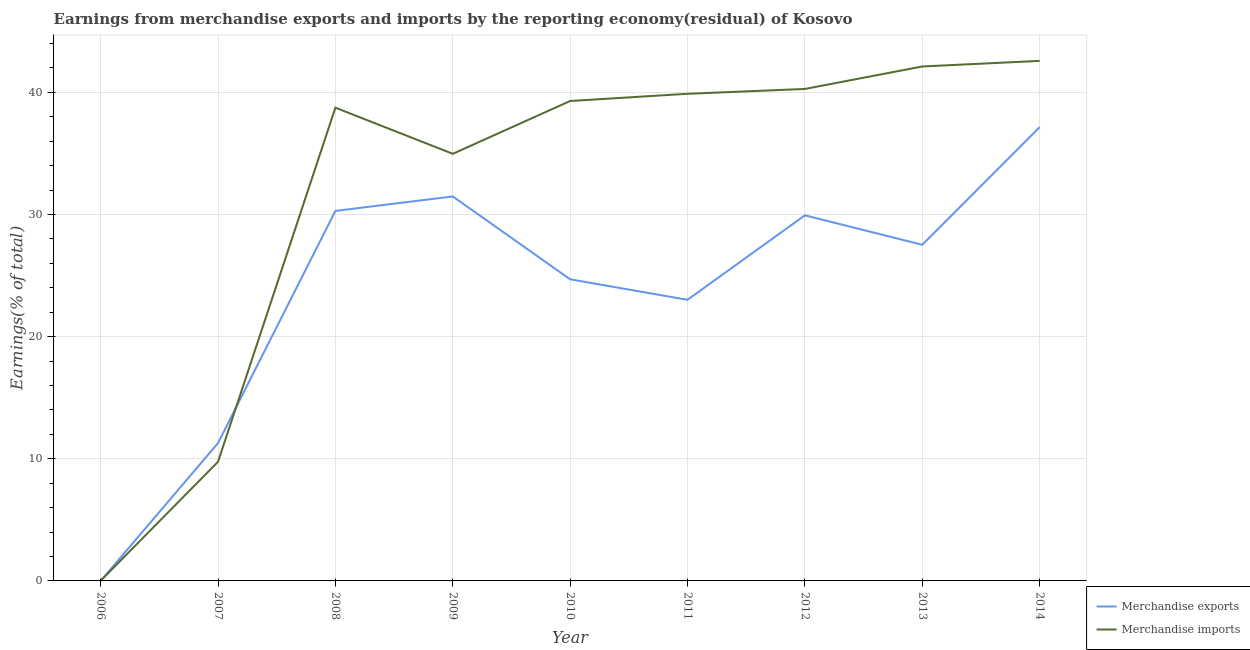Is the number of lines equal to the number of legend labels?
Make the answer very short. Yes. What is the earnings from merchandise imports in 2011?
Your answer should be very brief. 39.88. Across all years, what is the maximum earnings from merchandise imports?
Your answer should be compact. 42.57. Across all years, what is the minimum earnings from merchandise imports?
Your answer should be very brief. 0.01. In which year was the earnings from merchandise imports maximum?
Make the answer very short. 2014. What is the total earnings from merchandise exports in the graph?
Your answer should be compact. 215.36. What is the difference between the earnings from merchandise exports in 2006 and that in 2008?
Make the answer very short. -30.29. What is the difference between the earnings from merchandise imports in 2013 and the earnings from merchandise exports in 2008?
Provide a succinct answer. 11.82. What is the average earnings from merchandise exports per year?
Make the answer very short. 23.93. In the year 2009, what is the difference between the earnings from merchandise exports and earnings from merchandise imports?
Keep it short and to the point. -3.49. In how many years, is the earnings from merchandise imports greater than 14 %?
Provide a succinct answer. 7. What is the ratio of the earnings from merchandise exports in 2008 to that in 2014?
Keep it short and to the point. 0.82. What is the difference between the highest and the second highest earnings from merchandise exports?
Give a very brief answer. 5.67. What is the difference between the highest and the lowest earnings from merchandise exports?
Your response must be concise. 37.15. In how many years, is the earnings from merchandise exports greater than the average earnings from merchandise exports taken over all years?
Make the answer very short. 6. Is the sum of the earnings from merchandise imports in 2006 and 2009 greater than the maximum earnings from merchandise exports across all years?
Provide a short and direct response. No. How many lines are there?
Provide a short and direct response. 2. How many years are there in the graph?
Give a very brief answer. 9. What is the difference between two consecutive major ticks on the Y-axis?
Ensure brevity in your answer.  10. Are the values on the major ticks of Y-axis written in scientific E-notation?
Your answer should be very brief. No. Where does the legend appear in the graph?
Make the answer very short. Bottom right. How are the legend labels stacked?
Your answer should be very brief. Vertical. What is the title of the graph?
Keep it short and to the point. Earnings from merchandise exports and imports by the reporting economy(residual) of Kosovo. What is the label or title of the Y-axis?
Keep it short and to the point. Earnings(% of total). What is the Earnings(% of total) in Merchandise exports in 2006?
Your response must be concise. 7.80569519437283e-9. What is the Earnings(% of total) in Merchandise imports in 2006?
Offer a terse response. 0.01. What is the Earnings(% of total) in Merchandise exports in 2007?
Give a very brief answer. 11.29. What is the Earnings(% of total) of Merchandise imports in 2007?
Offer a terse response. 9.76. What is the Earnings(% of total) of Merchandise exports in 2008?
Offer a terse response. 30.29. What is the Earnings(% of total) in Merchandise imports in 2008?
Give a very brief answer. 38.74. What is the Earnings(% of total) in Merchandise exports in 2009?
Your answer should be very brief. 31.48. What is the Earnings(% of total) of Merchandise imports in 2009?
Your answer should be compact. 34.97. What is the Earnings(% of total) in Merchandise exports in 2010?
Your answer should be compact. 24.69. What is the Earnings(% of total) in Merchandise imports in 2010?
Keep it short and to the point. 39.29. What is the Earnings(% of total) of Merchandise exports in 2011?
Make the answer very short. 23.02. What is the Earnings(% of total) of Merchandise imports in 2011?
Make the answer very short. 39.88. What is the Earnings(% of total) of Merchandise exports in 2012?
Give a very brief answer. 29.93. What is the Earnings(% of total) in Merchandise imports in 2012?
Your response must be concise. 40.28. What is the Earnings(% of total) in Merchandise exports in 2013?
Give a very brief answer. 27.52. What is the Earnings(% of total) in Merchandise imports in 2013?
Your response must be concise. 42.12. What is the Earnings(% of total) in Merchandise exports in 2014?
Make the answer very short. 37.15. What is the Earnings(% of total) of Merchandise imports in 2014?
Your answer should be very brief. 42.57. Across all years, what is the maximum Earnings(% of total) in Merchandise exports?
Give a very brief answer. 37.15. Across all years, what is the maximum Earnings(% of total) in Merchandise imports?
Make the answer very short. 42.57. Across all years, what is the minimum Earnings(% of total) of Merchandise exports?
Keep it short and to the point. 7.80569519437283e-9. Across all years, what is the minimum Earnings(% of total) of Merchandise imports?
Your answer should be compact. 0.01. What is the total Earnings(% of total) of Merchandise exports in the graph?
Offer a very short reply. 215.36. What is the total Earnings(% of total) of Merchandise imports in the graph?
Your answer should be very brief. 287.61. What is the difference between the Earnings(% of total) in Merchandise exports in 2006 and that in 2007?
Give a very brief answer. -11.29. What is the difference between the Earnings(% of total) of Merchandise imports in 2006 and that in 2007?
Offer a very short reply. -9.74. What is the difference between the Earnings(% of total) in Merchandise exports in 2006 and that in 2008?
Your answer should be compact. -30.29. What is the difference between the Earnings(% of total) in Merchandise imports in 2006 and that in 2008?
Provide a short and direct response. -38.73. What is the difference between the Earnings(% of total) in Merchandise exports in 2006 and that in 2009?
Offer a terse response. -31.48. What is the difference between the Earnings(% of total) in Merchandise imports in 2006 and that in 2009?
Your answer should be compact. -34.95. What is the difference between the Earnings(% of total) in Merchandise exports in 2006 and that in 2010?
Provide a short and direct response. -24.69. What is the difference between the Earnings(% of total) in Merchandise imports in 2006 and that in 2010?
Offer a terse response. -39.28. What is the difference between the Earnings(% of total) of Merchandise exports in 2006 and that in 2011?
Make the answer very short. -23.02. What is the difference between the Earnings(% of total) of Merchandise imports in 2006 and that in 2011?
Your answer should be compact. -39.87. What is the difference between the Earnings(% of total) in Merchandise exports in 2006 and that in 2012?
Give a very brief answer. -29.93. What is the difference between the Earnings(% of total) in Merchandise imports in 2006 and that in 2012?
Your answer should be very brief. -40.26. What is the difference between the Earnings(% of total) of Merchandise exports in 2006 and that in 2013?
Give a very brief answer. -27.52. What is the difference between the Earnings(% of total) in Merchandise imports in 2006 and that in 2013?
Keep it short and to the point. -42.1. What is the difference between the Earnings(% of total) in Merchandise exports in 2006 and that in 2014?
Offer a terse response. -37.15. What is the difference between the Earnings(% of total) in Merchandise imports in 2006 and that in 2014?
Ensure brevity in your answer.  -42.56. What is the difference between the Earnings(% of total) of Merchandise exports in 2007 and that in 2008?
Provide a succinct answer. -19.01. What is the difference between the Earnings(% of total) of Merchandise imports in 2007 and that in 2008?
Provide a short and direct response. -28.99. What is the difference between the Earnings(% of total) of Merchandise exports in 2007 and that in 2009?
Keep it short and to the point. -20.19. What is the difference between the Earnings(% of total) of Merchandise imports in 2007 and that in 2009?
Keep it short and to the point. -25.21. What is the difference between the Earnings(% of total) of Merchandise exports in 2007 and that in 2010?
Ensure brevity in your answer.  -13.4. What is the difference between the Earnings(% of total) in Merchandise imports in 2007 and that in 2010?
Your answer should be compact. -29.53. What is the difference between the Earnings(% of total) of Merchandise exports in 2007 and that in 2011?
Offer a terse response. -11.73. What is the difference between the Earnings(% of total) in Merchandise imports in 2007 and that in 2011?
Offer a very short reply. -30.12. What is the difference between the Earnings(% of total) in Merchandise exports in 2007 and that in 2012?
Ensure brevity in your answer.  -18.64. What is the difference between the Earnings(% of total) of Merchandise imports in 2007 and that in 2012?
Give a very brief answer. -30.52. What is the difference between the Earnings(% of total) in Merchandise exports in 2007 and that in 2013?
Your answer should be very brief. -16.23. What is the difference between the Earnings(% of total) in Merchandise imports in 2007 and that in 2013?
Provide a succinct answer. -32.36. What is the difference between the Earnings(% of total) of Merchandise exports in 2007 and that in 2014?
Offer a very short reply. -25.86. What is the difference between the Earnings(% of total) of Merchandise imports in 2007 and that in 2014?
Keep it short and to the point. -32.82. What is the difference between the Earnings(% of total) of Merchandise exports in 2008 and that in 2009?
Your answer should be very brief. -1.18. What is the difference between the Earnings(% of total) in Merchandise imports in 2008 and that in 2009?
Make the answer very short. 3.78. What is the difference between the Earnings(% of total) of Merchandise exports in 2008 and that in 2010?
Offer a very short reply. 5.6. What is the difference between the Earnings(% of total) of Merchandise imports in 2008 and that in 2010?
Make the answer very short. -0.55. What is the difference between the Earnings(% of total) in Merchandise exports in 2008 and that in 2011?
Keep it short and to the point. 7.28. What is the difference between the Earnings(% of total) in Merchandise imports in 2008 and that in 2011?
Offer a very short reply. -1.14. What is the difference between the Earnings(% of total) of Merchandise exports in 2008 and that in 2012?
Give a very brief answer. 0.36. What is the difference between the Earnings(% of total) in Merchandise imports in 2008 and that in 2012?
Make the answer very short. -1.53. What is the difference between the Earnings(% of total) in Merchandise exports in 2008 and that in 2013?
Offer a terse response. 2.77. What is the difference between the Earnings(% of total) of Merchandise imports in 2008 and that in 2013?
Provide a short and direct response. -3.37. What is the difference between the Earnings(% of total) in Merchandise exports in 2008 and that in 2014?
Your response must be concise. -6.86. What is the difference between the Earnings(% of total) of Merchandise imports in 2008 and that in 2014?
Your answer should be compact. -3.83. What is the difference between the Earnings(% of total) of Merchandise exports in 2009 and that in 2010?
Provide a succinct answer. 6.79. What is the difference between the Earnings(% of total) in Merchandise imports in 2009 and that in 2010?
Provide a succinct answer. -4.32. What is the difference between the Earnings(% of total) of Merchandise exports in 2009 and that in 2011?
Provide a short and direct response. 8.46. What is the difference between the Earnings(% of total) of Merchandise imports in 2009 and that in 2011?
Your answer should be very brief. -4.91. What is the difference between the Earnings(% of total) in Merchandise exports in 2009 and that in 2012?
Ensure brevity in your answer.  1.55. What is the difference between the Earnings(% of total) in Merchandise imports in 2009 and that in 2012?
Make the answer very short. -5.31. What is the difference between the Earnings(% of total) of Merchandise exports in 2009 and that in 2013?
Give a very brief answer. 3.96. What is the difference between the Earnings(% of total) in Merchandise imports in 2009 and that in 2013?
Your response must be concise. -7.15. What is the difference between the Earnings(% of total) in Merchandise exports in 2009 and that in 2014?
Make the answer very short. -5.67. What is the difference between the Earnings(% of total) in Merchandise imports in 2009 and that in 2014?
Make the answer very short. -7.61. What is the difference between the Earnings(% of total) of Merchandise exports in 2010 and that in 2011?
Your answer should be very brief. 1.68. What is the difference between the Earnings(% of total) of Merchandise imports in 2010 and that in 2011?
Your answer should be compact. -0.59. What is the difference between the Earnings(% of total) of Merchandise exports in 2010 and that in 2012?
Your answer should be very brief. -5.24. What is the difference between the Earnings(% of total) of Merchandise imports in 2010 and that in 2012?
Your answer should be very brief. -0.99. What is the difference between the Earnings(% of total) of Merchandise exports in 2010 and that in 2013?
Provide a succinct answer. -2.83. What is the difference between the Earnings(% of total) in Merchandise imports in 2010 and that in 2013?
Offer a very short reply. -2.83. What is the difference between the Earnings(% of total) of Merchandise exports in 2010 and that in 2014?
Your answer should be very brief. -12.46. What is the difference between the Earnings(% of total) of Merchandise imports in 2010 and that in 2014?
Make the answer very short. -3.28. What is the difference between the Earnings(% of total) in Merchandise exports in 2011 and that in 2012?
Provide a succinct answer. -6.92. What is the difference between the Earnings(% of total) of Merchandise imports in 2011 and that in 2012?
Your answer should be very brief. -0.4. What is the difference between the Earnings(% of total) of Merchandise exports in 2011 and that in 2013?
Your answer should be very brief. -4.5. What is the difference between the Earnings(% of total) in Merchandise imports in 2011 and that in 2013?
Provide a short and direct response. -2.24. What is the difference between the Earnings(% of total) in Merchandise exports in 2011 and that in 2014?
Offer a very short reply. -14.14. What is the difference between the Earnings(% of total) in Merchandise imports in 2011 and that in 2014?
Provide a succinct answer. -2.69. What is the difference between the Earnings(% of total) in Merchandise exports in 2012 and that in 2013?
Your answer should be compact. 2.41. What is the difference between the Earnings(% of total) of Merchandise imports in 2012 and that in 2013?
Offer a very short reply. -1.84. What is the difference between the Earnings(% of total) of Merchandise exports in 2012 and that in 2014?
Offer a terse response. -7.22. What is the difference between the Earnings(% of total) of Merchandise imports in 2012 and that in 2014?
Your answer should be compact. -2.3. What is the difference between the Earnings(% of total) of Merchandise exports in 2013 and that in 2014?
Your response must be concise. -9.63. What is the difference between the Earnings(% of total) in Merchandise imports in 2013 and that in 2014?
Offer a very short reply. -0.46. What is the difference between the Earnings(% of total) of Merchandise exports in 2006 and the Earnings(% of total) of Merchandise imports in 2007?
Offer a terse response. -9.76. What is the difference between the Earnings(% of total) in Merchandise exports in 2006 and the Earnings(% of total) in Merchandise imports in 2008?
Give a very brief answer. -38.74. What is the difference between the Earnings(% of total) in Merchandise exports in 2006 and the Earnings(% of total) in Merchandise imports in 2009?
Provide a succinct answer. -34.97. What is the difference between the Earnings(% of total) in Merchandise exports in 2006 and the Earnings(% of total) in Merchandise imports in 2010?
Make the answer very short. -39.29. What is the difference between the Earnings(% of total) in Merchandise exports in 2006 and the Earnings(% of total) in Merchandise imports in 2011?
Keep it short and to the point. -39.88. What is the difference between the Earnings(% of total) in Merchandise exports in 2006 and the Earnings(% of total) in Merchandise imports in 2012?
Provide a short and direct response. -40.28. What is the difference between the Earnings(% of total) of Merchandise exports in 2006 and the Earnings(% of total) of Merchandise imports in 2013?
Give a very brief answer. -42.12. What is the difference between the Earnings(% of total) in Merchandise exports in 2006 and the Earnings(% of total) in Merchandise imports in 2014?
Provide a succinct answer. -42.57. What is the difference between the Earnings(% of total) of Merchandise exports in 2007 and the Earnings(% of total) of Merchandise imports in 2008?
Offer a very short reply. -27.46. What is the difference between the Earnings(% of total) in Merchandise exports in 2007 and the Earnings(% of total) in Merchandise imports in 2009?
Offer a very short reply. -23.68. What is the difference between the Earnings(% of total) of Merchandise exports in 2007 and the Earnings(% of total) of Merchandise imports in 2010?
Provide a short and direct response. -28. What is the difference between the Earnings(% of total) in Merchandise exports in 2007 and the Earnings(% of total) in Merchandise imports in 2011?
Give a very brief answer. -28.59. What is the difference between the Earnings(% of total) in Merchandise exports in 2007 and the Earnings(% of total) in Merchandise imports in 2012?
Offer a very short reply. -28.99. What is the difference between the Earnings(% of total) of Merchandise exports in 2007 and the Earnings(% of total) of Merchandise imports in 2013?
Your answer should be very brief. -30.83. What is the difference between the Earnings(% of total) of Merchandise exports in 2007 and the Earnings(% of total) of Merchandise imports in 2014?
Your response must be concise. -31.29. What is the difference between the Earnings(% of total) of Merchandise exports in 2008 and the Earnings(% of total) of Merchandise imports in 2009?
Offer a terse response. -4.67. What is the difference between the Earnings(% of total) in Merchandise exports in 2008 and the Earnings(% of total) in Merchandise imports in 2010?
Give a very brief answer. -9. What is the difference between the Earnings(% of total) of Merchandise exports in 2008 and the Earnings(% of total) of Merchandise imports in 2011?
Give a very brief answer. -9.59. What is the difference between the Earnings(% of total) in Merchandise exports in 2008 and the Earnings(% of total) in Merchandise imports in 2012?
Make the answer very short. -9.98. What is the difference between the Earnings(% of total) in Merchandise exports in 2008 and the Earnings(% of total) in Merchandise imports in 2013?
Keep it short and to the point. -11.82. What is the difference between the Earnings(% of total) in Merchandise exports in 2008 and the Earnings(% of total) in Merchandise imports in 2014?
Keep it short and to the point. -12.28. What is the difference between the Earnings(% of total) of Merchandise exports in 2009 and the Earnings(% of total) of Merchandise imports in 2010?
Your answer should be very brief. -7.81. What is the difference between the Earnings(% of total) in Merchandise exports in 2009 and the Earnings(% of total) in Merchandise imports in 2011?
Make the answer very short. -8.4. What is the difference between the Earnings(% of total) of Merchandise exports in 2009 and the Earnings(% of total) of Merchandise imports in 2012?
Your answer should be very brief. -8.8. What is the difference between the Earnings(% of total) in Merchandise exports in 2009 and the Earnings(% of total) in Merchandise imports in 2013?
Offer a very short reply. -10.64. What is the difference between the Earnings(% of total) in Merchandise exports in 2009 and the Earnings(% of total) in Merchandise imports in 2014?
Offer a terse response. -11.1. What is the difference between the Earnings(% of total) in Merchandise exports in 2010 and the Earnings(% of total) in Merchandise imports in 2011?
Your answer should be very brief. -15.19. What is the difference between the Earnings(% of total) of Merchandise exports in 2010 and the Earnings(% of total) of Merchandise imports in 2012?
Make the answer very short. -15.58. What is the difference between the Earnings(% of total) of Merchandise exports in 2010 and the Earnings(% of total) of Merchandise imports in 2013?
Your response must be concise. -17.42. What is the difference between the Earnings(% of total) in Merchandise exports in 2010 and the Earnings(% of total) in Merchandise imports in 2014?
Give a very brief answer. -17.88. What is the difference between the Earnings(% of total) in Merchandise exports in 2011 and the Earnings(% of total) in Merchandise imports in 2012?
Give a very brief answer. -17.26. What is the difference between the Earnings(% of total) of Merchandise exports in 2011 and the Earnings(% of total) of Merchandise imports in 2013?
Offer a very short reply. -19.1. What is the difference between the Earnings(% of total) of Merchandise exports in 2011 and the Earnings(% of total) of Merchandise imports in 2014?
Keep it short and to the point. -19.56. What is the difference between the Earnings(% of total) of Merchandise exports in 2012 and the Earnings(% of total) of Merchandise imports in 2013?
Your response must be concise. -12.18. What is the difference between the Earnings(% of total) in Merchandise exports in 2012 and the Earnings(% of total) in Merchandise imports in 2014?
Offer a very short reply. -12.64. What is the difference between the Earnings(% of total) in Merchandise exports in 2013 and the Earnings(% of total) in Merchandise imports in 2014?
Make the answer very short. -15.06. What is the average Earnings(% of total) in Merchandise exports per year?
Keep it short and to the point. 23.93. What is the average Earnings(% of total) of Merchandise imports per year?
Offer a terse response. 31.96. In the year 2006, what is the difference between the Earnings(% of total) in Merchandise exports and Earnings(% of total) in Merchandise imports?
Offer a terse response. -0.01. In the year 2007, what is the difference between the Earnings(% of total) in Merchandise exports and Earnings(% of total) in Merchandise imports?
Provide a short and direct response. 1.53. In the year 2008, what is the difference between the Earnings(% of total) of Merchandise exports and Earnings(% of total) of Merchandise imports?
Offer a very short reply. -8.45. In the year 2009, what is the difference between the Earnings(% of total) of Merchandise exports and Earnings(% of total) of Merchandise imports?
Your answer should be compact. -3.49. In the year 2010, what is the difference between the Earnings(% of total) of Merchandise exports and Earnings(% of total) of Merchandise imports?
Ensure brevity in your answer.  -14.6. In the year 2011, what is the difference between the Earnings(% of total) in Merchandise exports and Earnings(% of total) in Merchandise imports?
Your answer should be very brief. -16.86. In the year 2012, what is the difference between the Earnings(% of total) in Merchandise exports and Earnings(% of total) in Merchandise imports?
Give a very brief answer. -10.35. In the year 2013, what is the difference between the Earnings(% of total) of Merchandise exports and Earnings(% of total) of Merchandise imports?
Keep it short and to the point. -14.6. In the year 2014, what is the difference between the Earnings(% of total) in Merchandise exports and Earnings(% of total) in Merchandise imports?
Keep it short and to the point. -5.42. What is the ratio of the Earnings(% of total) in Merchandise exports in 2006 to that in 2007?
Provide a short and direct response. 0. What is the ratio of the Earnings(% of total) of Merchandise imports in 2006 to that in 2007?
Your answer should be compact. 0. What is the ratio of the Earnings(% of total) in Merchandise imports in 2006 to that in 2008?
Make the answer very short. 0. What is the ratio of the Earnings(% of total) of Merchandise exports in 2006 to that in 2009?
Your answer should be compact. 0. What is the ratio of the Earnings(% of total) in Merchandise imports in 2006 to that in 2010?
Provide a succinct answer. 0. What is the ratio of the Earnings(% of total) in Merchandise imports in 2006 to that in 2011?
Your answer should be compact. 0. What is the ratio of the Earnings(% of total) in Merchandise exports in 2006 to that in 2012?
Ensure brevity in your answer.  0. What is the ratio of the Earnings(% of total) in Merchandise imports in 2006 to that in 2012?
Offer a terse response. 0. What is the ratio of the Earnings(% of total) in Merchandise imports in 2006 to that in 2014?
Your answer should be compact. 0. What is the ratio of the Earnings(% of total) of Merchandise exports in 2007 to that in 2008?
Your answer should be very brief. 0.37. What is the ratio of the Earnings(% of total) of Merchandise imports in 2007 to that in 2008?
Your response must be concise. 0.25. What is the ratio of the Earnings(% of total) in Merchandise exports in 2007 to that in 2009?
Your answer should be very brief. 0.36. What is the ratio of the Earnings(% of total) in Merchandise imports in 2007 to that in 2009?
Give a very brief answer. 0.28. What is the ratio of the Earnings(% of total) of Merchandise exports in 2007 to that in 2010?
Your answer should be very brief. 0.46. What is the ratio of the Earnings(% of total) of Merchandise imports in 2007 to that in 2010?
Your answer should be very brief. 0.25. What is the ratio of the Earnings(% of total) in Merchandise exports in 2007 to that in 2011?
Offer a terse response. 0.49. What is the ratio of the Earnings(% of total) of Merchandise imports in 2007 to that in 2011?
Give a very brief answer. 0.24. What is the ratio of the Earnings(% of total) of Merchandise exports in 2007 to that in 2012?
Your answer should be compact. 0.38. What is the ratio of the Earnings(% of total) in Merchandise imports in 2007 to that in 2012?
Your response must be concise. 0.24. What is the ratio of the Earnings(% of total) in Merchandise exports in 2007 to that in 2013?
Provide a succinct answer. 0.41. What is the ratio of the Earnings(% of total) of Merchandise imports in 2007 to that in 2013?
Your answer should be compact. 0.23. What is the ratio of the Earnings(% of total) in Merchandise exports in 2007 to that in 2014?
Your answer should be compact. 0.3. What is the ratio of the Earnings(% of total) in Merchandise imports in 2007 to that in 2014?
Ensure brevity in your answer.  0.23. What is the ratio of the Earnings(% of total) in Merchandise exports in 2008 to that in 2009?
Ensure brevity in your answer.  0.96. What is the ratio of the Earnings(% of total) of Merchandise imports in 2008 to that in 2009?
Provide a short and direct response. 1.11. What is the ratio of the Earnings(% of total) of Merchandise exports in 2008 to that in 2010?
Your answer should be compact. 1.23. What is the ratio of the Earnings(% of total) of Merchandise imports in 2008 to that in 2010?
Your answer should be compact. 0.99. What is the ratio of the Earnings(% of total) in Merchandise exports in 2008 to that in 2011?
Provide a short and direct response. 1.32. What is the ratio of the Earnings(% of total) of Merchandise imports in 2008 to that in 2011?
Provide a succinct answer. 0.97. What is the ratio of the Earnings(% of total) of Merchandise exports in 2008 to that in 2012?
Ensure brevity in your answer.  1.01. What is the ratio of the Earnings(% of total) in Merchandise imports in 2008 to that in 2012?
Provide a short and direct response. 0.96. What is the ratio of the Earnings(% of total) in Merchandise exports in 2008 to that in 2013?
Offer a terse response. 1.1. What is the ratio of the Earnings(% of total) in Merchandise imports in 2008 to that in 2013?
Your answer should be very brief. 0.92. What is the ratio of the Earnings(% of total) in Merchandise exports in 2008 to that in 2014?
Provide a succinct answer. 0.82. What is the ratio of the Earnings(% of total) of Merchandise imports in 2008 to that in 2014?
Provide a succinct answer. 0.91. What is the ratio of the Earnings(% of total) of Merchandise exports in 2009 to that in 2010?
Provide a short and direct response. 1.27. What is the ratio of the Earnings(% of total) of Merchandise imports in 2009 to that in 2010?
Your answer should be compact. 0.89. What is the ratio of the Earnings(% of total) in Merchandise exports in 2009 to that in 2011?
Your answer should be very brief. 1.37. What is the ratio of the Earnings(% of total) in Merchandise imports in 2009 to that in 2011?
Give a very brief answer. 0.88. What is the ratio of the Earnings(% of total) in Merchandise exports in 2009 to that in 2012?
Ensure brevity in your answer.  1.05. What is the ratio of the Earnings(% of total) in Merchandise imports in 2009 to that in 2012?
Give a very brief answer. 0.87. What is the ratio of the Earnings(% of total) of Merchandise exports in 2009 to that in 2013?
Keep it short and to the point. 1.14. What is the ratio of the Earnings(% of total) of Merchandise imports in 2009 to that in 2013?
Your answer should be compact. 0.83. What is the ratio of the Earnings(% of total) of Merchandise exports in 2009 to that in 2014?
Keep it short and to the point. 0.85. What is the ratio of the Earnings(% of total) of Merchandise imports in 2009 to that in 2014?
Offer a very short reply. 0.82. What is the ratio of the Earnings(% of total) of Merchandise exports in 2010 to that in 2011?
Keep it short and to the point. 1.07. What is the ratio of the Earnings(% of total) of Merchandise imports in 2010 to that in 2011?
Your response must be concise. 0.99. What is the ratio of the Earnings(% of total) in Merchandise exports in 2010 to that in 2012?
Your answer should be very brief. 0.82. What is the ratio of the Earnings(% of total) in Merchandise imports in 2010 to that in 2012?
Your answer should be very brief. 0.98. What is the ratio of the Earnings(% of total) in Merchandise exports in 2010 to that in 2013?
Provide a short and direct response. 0.9. What is the ratio of the Earnings(% of total) in Merchandise imports in 2010 to that in 2013?
Offer a terse response. 0.93. What is the ratio of the Earnings(% of total) in Merchandise exports in 2010 to that in 2014?
Give a very brief answer. 0.66. What is the ratio of the Earnings(% of total) of Merchandise imports in 2010 to that in 2014?
Your response must be concise. 0.92. What is the ratio of the Earnings(% of total) in Merchandise exports in 2011 to that in 2012?
Provide a succinct answer. 0.77. What is the ratio of the Earnings(% of total) in Merchandise imports in 2011 to that in 2012?
Keep it short and to the point. 0.99. What is the ratio of the Earnings(% of total) of Merchandise exports in 2011 to that in 2013?
Your answer should be compact. 0.84. What is the ratio of the Earnings(% of total) in Merchandise imports in 2011 to that in 2013?
Your response must be concise. 0.95. What is the ratio of the Earnings(% of total) of Merchandise exports in 2011 to that in 2014?
Keep it short and to the point. 0.62. What is the ratio of the Earnings(% of total) in Merchandise imports in 2011 to that in 2014?
Your answer should be very brief. 0.94. What is the ratio of the Earnings(% of total) of Merchandise exports in 2012 to that in 2013?
Your answer should be compact. 1.09. What is the ratio of the Earnings(% of total) of Merchandise imports in 2012 to that in 2013?
Make the answer very short. 0.96. What is the ratio of the Earnings(% of total) in Merchandise exports in 2012 to that in 2014?
Give a very brief answer. 0.81. What is the ratio of the Earnings(% of total) in Merchandise imports in 2012 to that in 2014?
Provide a short and direct response. 0.95. What is the ratio of the Earnings(% of total) in Merchandise exports in 2013 to that in 2014?
Provide a succinct answer. 0.74. What is the ratio of the Earnings(% of total) in Merchandise imports in 2013 to that in 2014?
Ensure brevity in your answer.  0.99. What is the difference between the highest and the second highest Earnings(% of total) of Merchandise exports?
Offer a very short reply. 5.67. What is the difference between the highest and the second highest Earnings(% of total) of Merchandise imports?
Keep it short and to the point. 0.46. What is the difference between the highest and the lowest Earnings(% of total) in Merchandise exports?
Provide a succinct answer. 37.15. What is the difference between the highest and the lowest Earnings(% of total) in Merchandise imports?
Give a very brief answer. 42.56. 